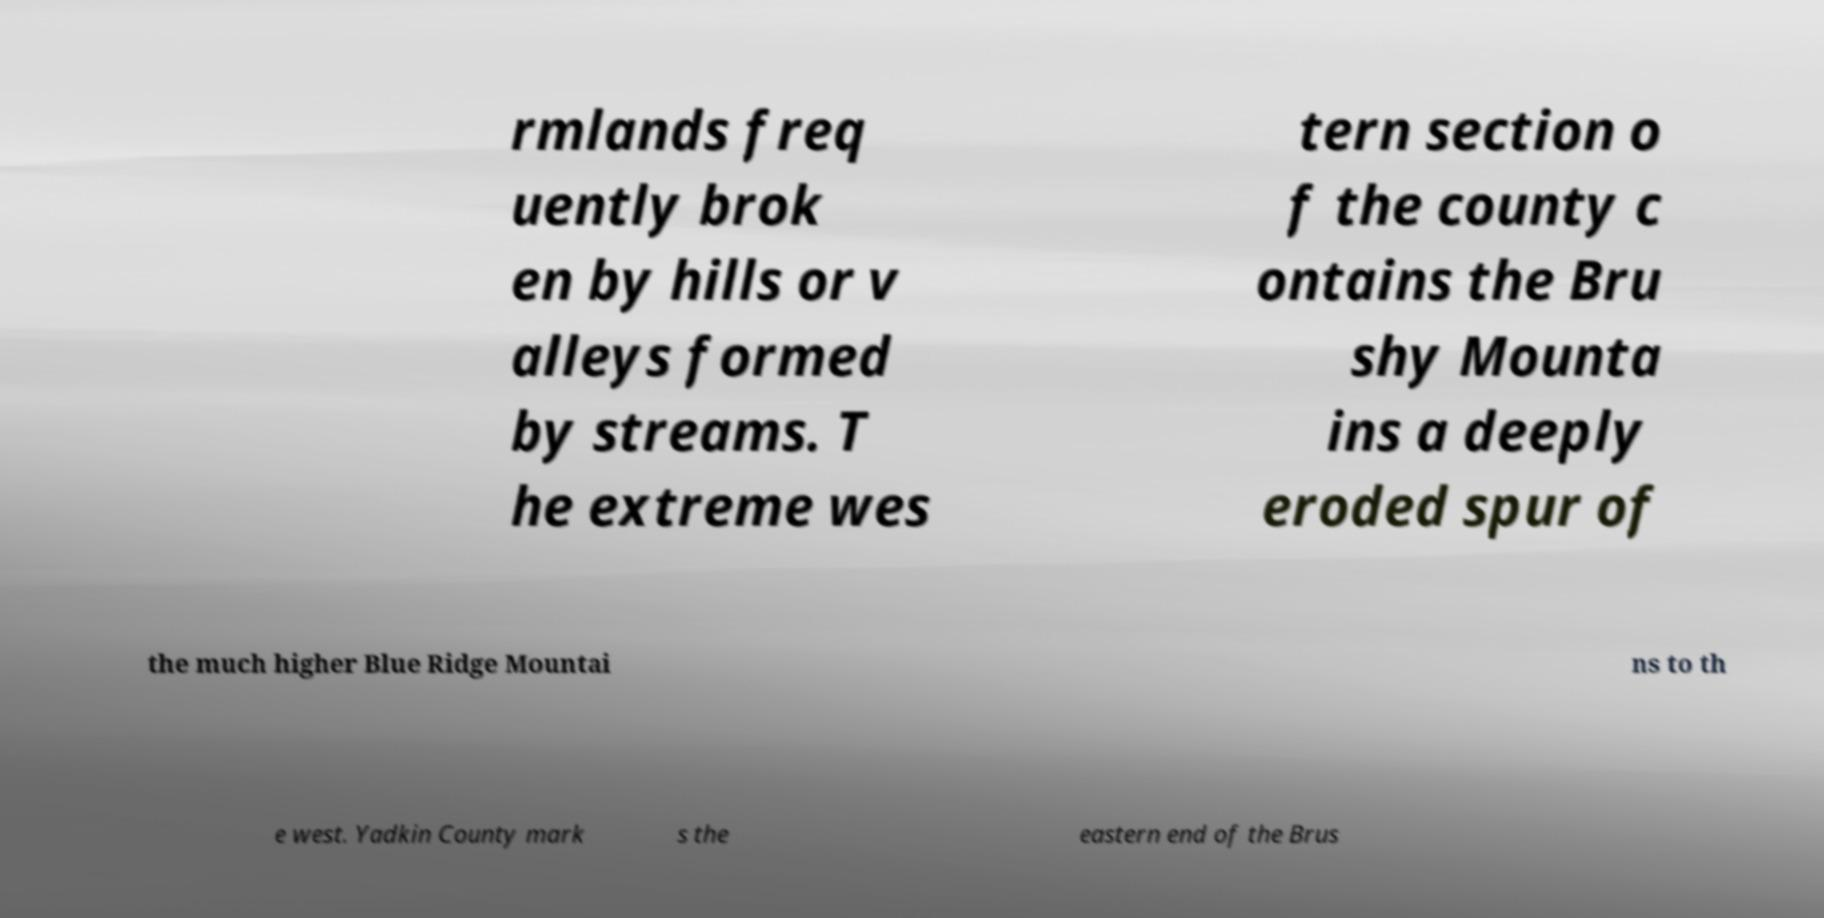Can you accurately transcribe the text from the provided image for me? rmlands freq uently brok en by hills or v alleys formed by streams. T he extreme wes tern section o f the county c ontains the Bru shy Mounta ins a deeply eroded spur of the much higher Blue Ridge Mountai ns to th e west. Yadkin County mark s the eastern end of the Brus 